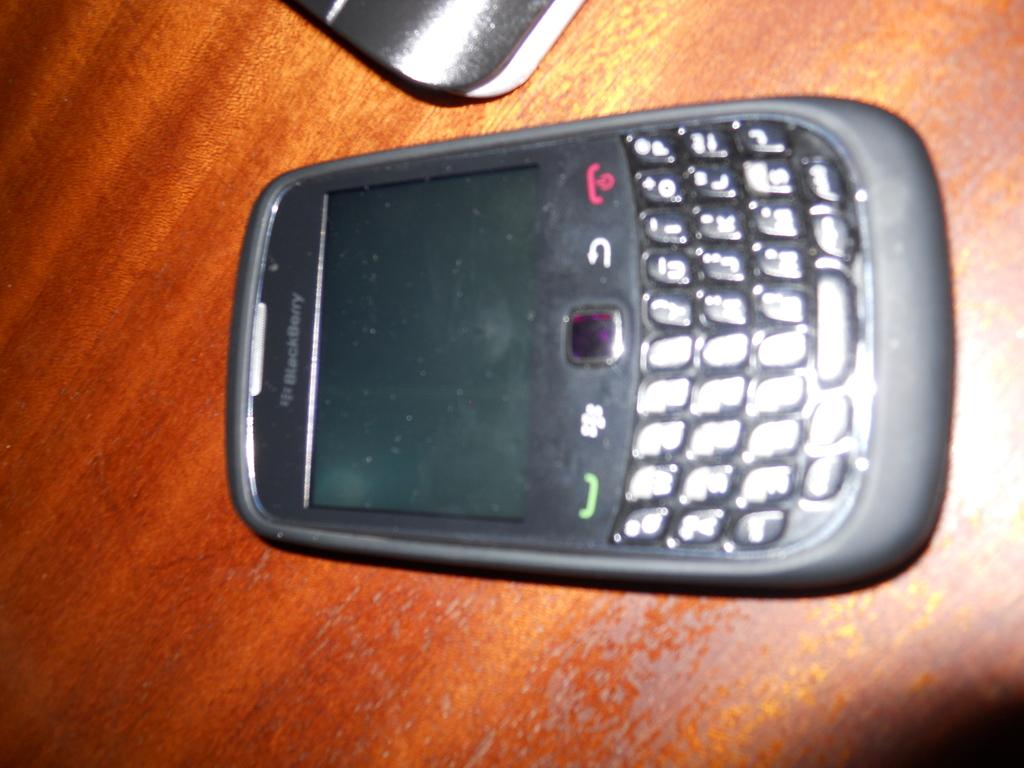What kind of phone is this?
Your answer should be very brief. Blackberry. 